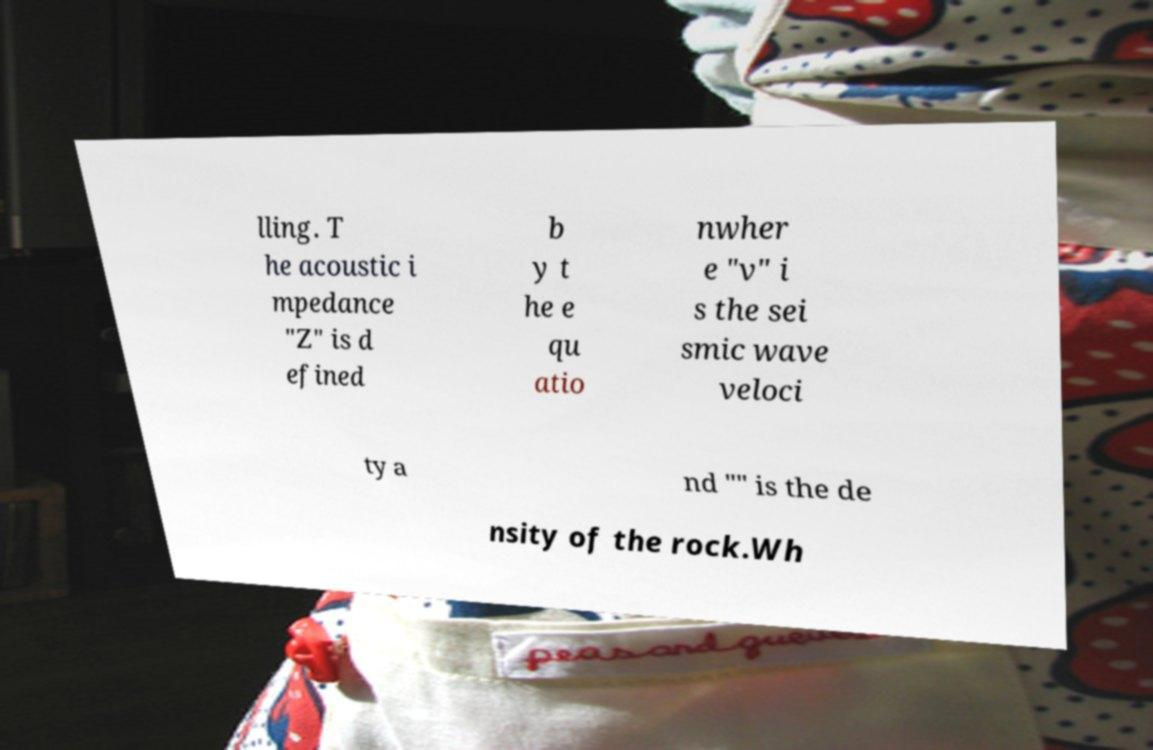Could you extract and type out the text from this image? lling. T he acoustic i mpedance "Z" is d efined b y t he e qu atio nwher e "v" i s the sei smic wave veloci ty a nd "" is the de nsity of the rock.Wh 